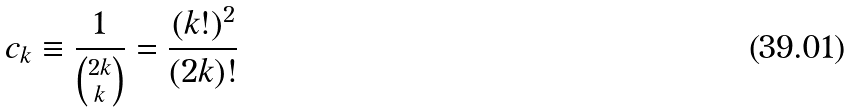<formula> <loc_0><loc_0><loc_500><loc_500>c _ { k } \equiv \frac { 1 } { \binom { 2 k } { k } } = \frac { ( k ! ) ^ { 2 } } { ( 2 k ) ! }</formula> 